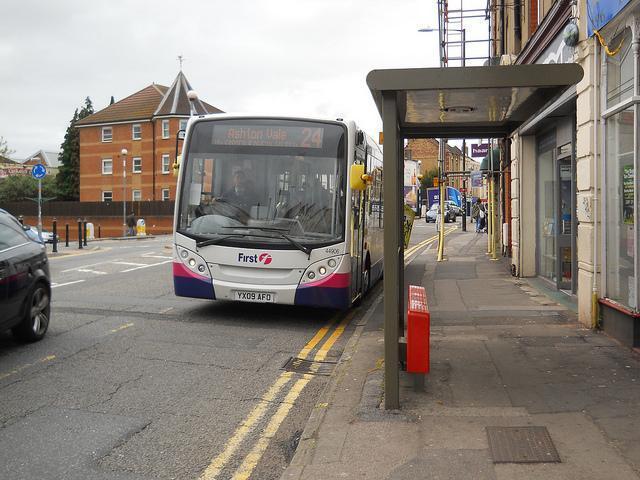Where is this bus headed next?
Choose the right answer from the provided options to respond to the question.
Options: Jail, ashton vale, first street, 24th street. Ashton vale. 